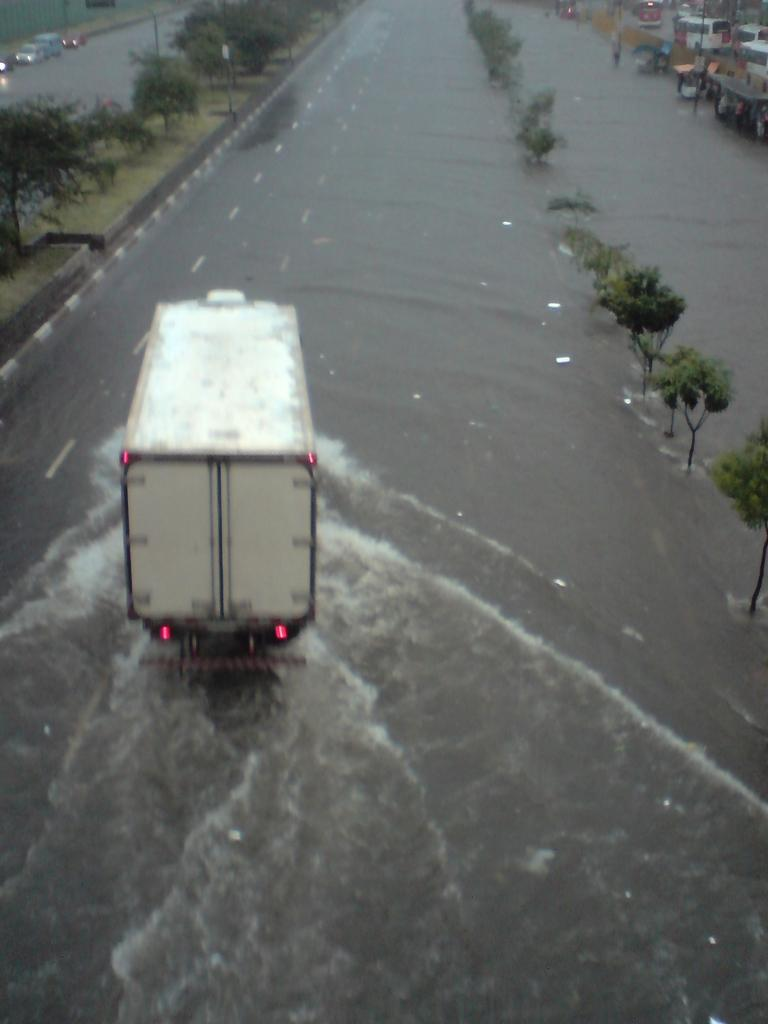What can be seen parked on the road in the image? There is a group of vehicles parked on the road in the image. What is visible in the foreground of the image? There is water visible in the foreground. What can be seen in the background of the image? There is a group of trees in the background, and there are items placed on the ground. What type of yam is being used as a prop for the band in the image? There is no yam or band present in the image. What kind of net is being used to catch fish in the image? There is no net or fishing activity depicted in the image. 